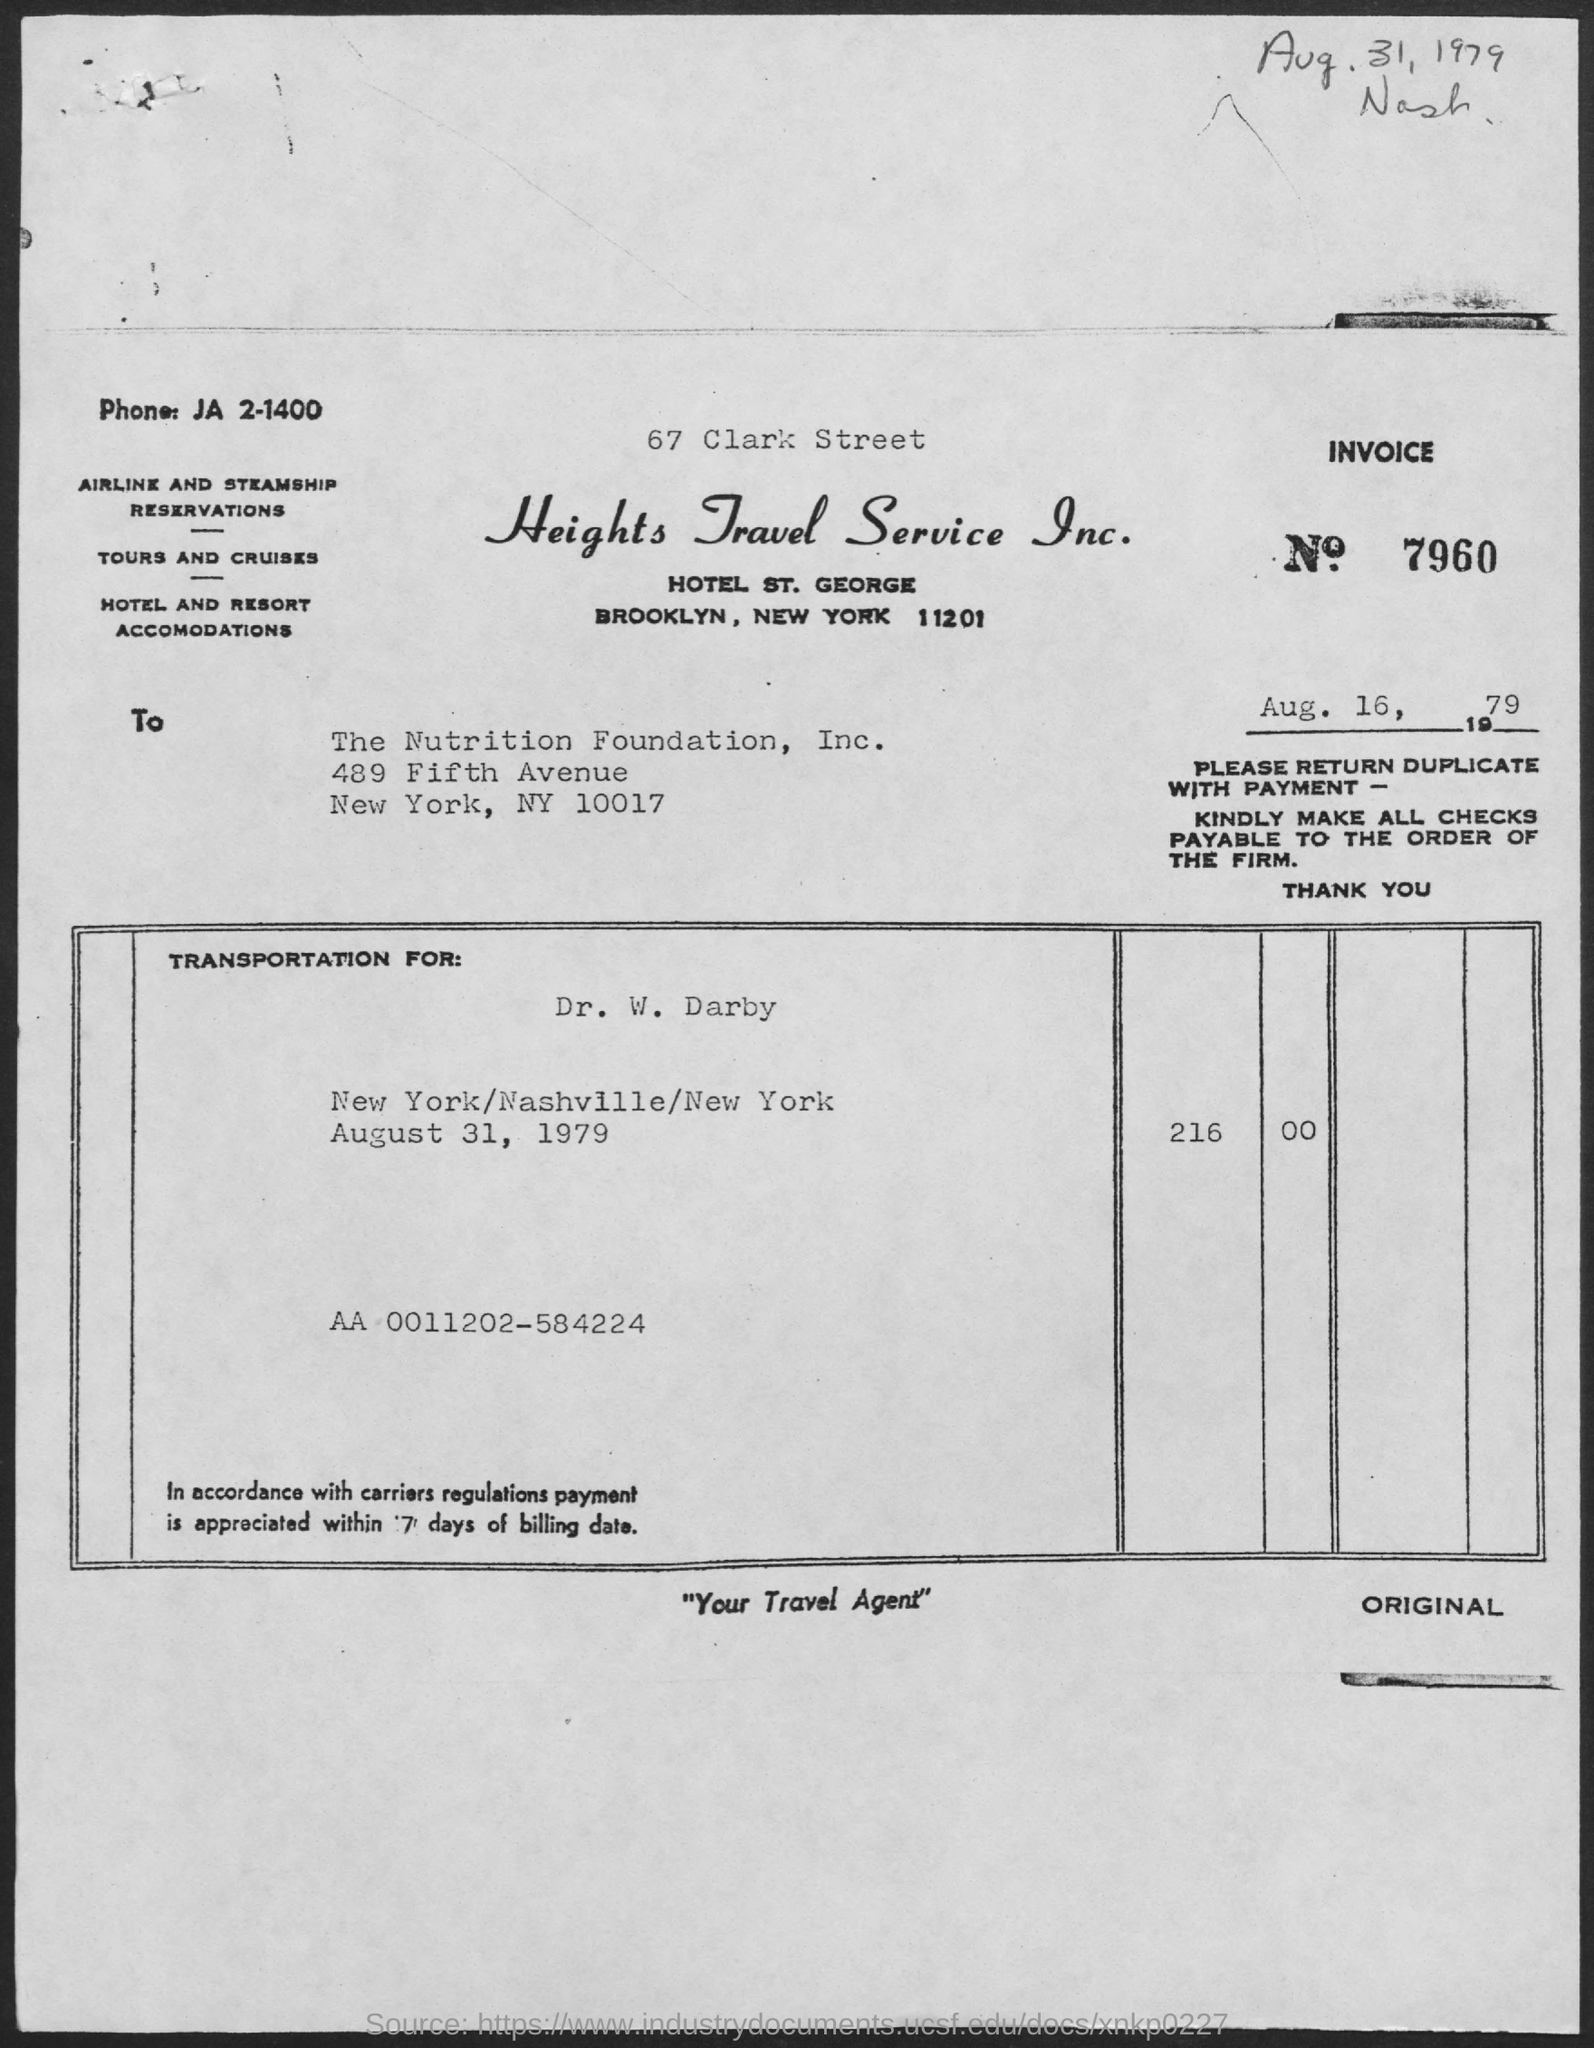List a handful of essential elements in this visual. Heights Travel Service is a company name. The memorandum is addressed to the Nutrition Foundation, Inc. The INVOICE number is 7960. The phone number is JA 2-1400. 